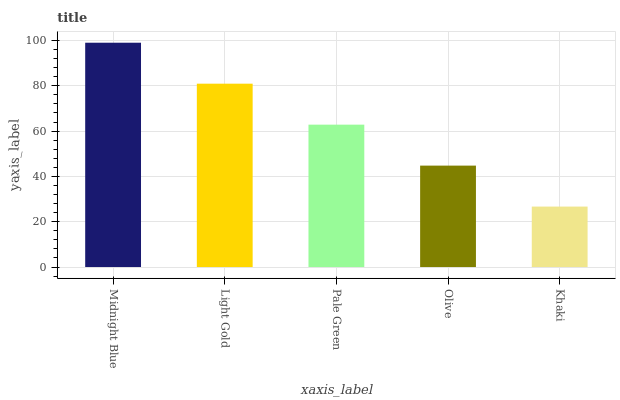Is Khaki the minimum?
Answer yes or no. Yes. Is Midnight Blue the maximum?
Answer yes or no. Yes. Is Light Gold the minimum?
Answer yes or no. No. Is Light Gold the maximum?
Answer yes or no. No. Is Midnight Blue greater than Light Gold?
Answer yes or no. Yes. Is Light Gold less than Midnight Blue?
Answer yes or no. Yes. Is Light Gold greater than Midnight Blue?
Answer yes or no. No. Is Midnight Blue less than Light Gold?
Answer yes or no. No. Is Pale Green the high median?
Answer yes or no. Yes. Is Pale Green the low median?
Answer yes or no. Yes. Is Light Gold the high median?
Answer yes or no. No. Is Olive the low median?
Answer yes or no. No. 